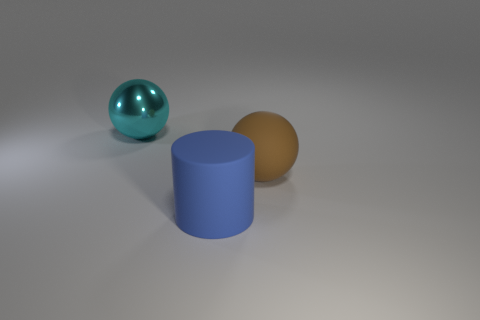Add 3 big cylinders. How many objects exist? 6 Subtract all cyan spheres. How many spheres are left? 1 Subtract all balls. How many objects are left? 1 Add 1 cyan objects. How many cyan objects exist? 2 Subtract 1 brown spheres. How many objects are left? 2 Subtract all blue spheres. Subtract all green blocks. How many spheres are left? 2 Subtract all green cubes. How many gray balls are left? 0 Subtract all matte things. Subtract all purple matte blocks. How many objects are left? 1 Add 2 large matte cylinders. How many large matte cylinders are left? 3 